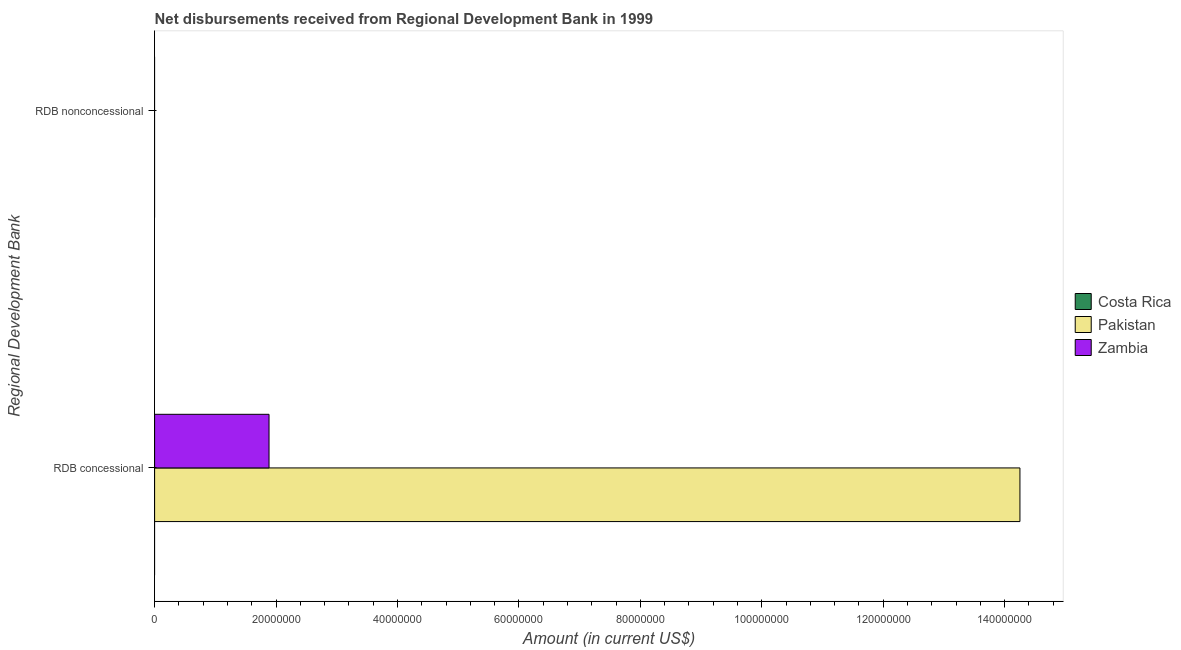Are the number of bars per tick equal to the number of legend labels?
Make the answer very short. No. Are the number of bars on each tick of the Y-axis equal?
Ensure brevity in your answer.  No. How many bars are there on the 2nd tick from the bottom?
Ensure brevity in your answer.  0. What is the label of the 1st group of bars from the top?
Provide a short and direct response. RDB nonconcessional. What is the net non concessional disbursements from rdb in Pakistan?
Give a very brief answer. 0. Across all countries, what is the maximum net concessional disbursements from rdb?
Your answer should be compact. 1.43e+08. Across all countries, what is the minimum net non concessional disbursements from rdb?
Keep it short and to the point. 0. What is the total net concessional disbursements from rdb in the graph?
Offer a very short reply. 1.61e+08. What is the difference between the net concessional disbursements from rdb in Zambia and that in Pakistan?
Make the answer very short. -1.24e+08. What is the difference between the net non concessional disbursements from rdb in Pakistan and the net concessional disbursements from rdb in Costa Rica?
Make the answer very short. 0. What is the average net non concessional disbursements from rdb per country?
Your answer should be compact. 0. What is the ratio of the net concessional disbursements from rdb in Zambia to that in Pakistan?
Give a very brief answer. 0.13. How many bars are there?
Offer a terse response. 2. Does the graph contain grids?
Keep it short and to the point. No. What is the title of the graph?
Offer a very short reply. Net disbursements received from Regional Development Bank in 1999. Does "Equatorial Guinea" appear as one of the legend labels in the graph?
Make the answer very short. No. What is the label or title of the Y-axis?
Provide a short and direct response. Regional Development Bank. What is the Amount (in current US$) in Costa Rica in RDB concessional?
Make the answer very short. 0. What is the Amount (in current US$) in Pakistan in RDB concessional?
Make the answer very short. 1.43e+08. What is the Amount (in current US$) in Zambia in RDB concessional?
Ensure brevity in your answer.  1.88e+07. What is the Amount (in current US$) of Pakistan in RDB nonconcessional?
Offer a terse response. 0. Across all Regional Development Bank, what is the maximum Amount (in current US$) in Pakistan?
Keep it short and to the point. 1.43e+08. Across all Regional Development Bank, what is the maximum Amount (in current US$) in Zambia?
Offer a terse response. 1.88e+07. Across all Regional Development Bank, what is the minimum Amount (in current US$) of Zambia?
Your answer should be very brief. 0. What is the total Amount (in current US$) of Pakistan in the graph?
Offer a terse response. 1.43e+08. What is the total Amount (in current US$) of Zambia in the graph?
Offer a very short reply. 1.88e+07. What is the average Amount (in current US$) of Costa Rica per Regional Development Bank?
Provide a succinct answer. 0. What is the average Amount (in current US$) of Pakistan per Regional Development Bank?
Keep it short and to the point. 7.13e+07. What is the average Amount (in current US$) of Zambia per Regional Development Bank?
Keep it short and to the point. 9.42e+06. What is the difference between the Amount (in current US$) of Pakistan and Amount (in current US$) of Zambia in RDB concessional?
Provide a succinct answer. 1.24e+08. What is the difference between the highest and the lowest Amount (in current US$) in Pakistan?
Your answer should be very brief. 1.43e+08. What is the difference between the highest and the lowest Amount (in current US$) in Zambia?
Offer a very short reply. 1.88e+07. 